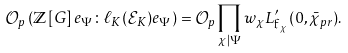<formula> <loc_0><loc_0><loc_500><loc_500>\mathcal { O } _ { p } \left ( \mathbb { Z } \left [ G \right ] e _ { \Psi } \colon \ell _ { K } ( \mathcal { E } _ { K } ) e _ { \Psi } \right ) = \mathcal { O } _ { p } \prod _ { \chi | \Psi } w _ { \chi } L ^ { \prime } _ { \mathfrak { f } _ { \chi } } ( 0 , \bar { \chi } _ { p r } ) .</formula> 